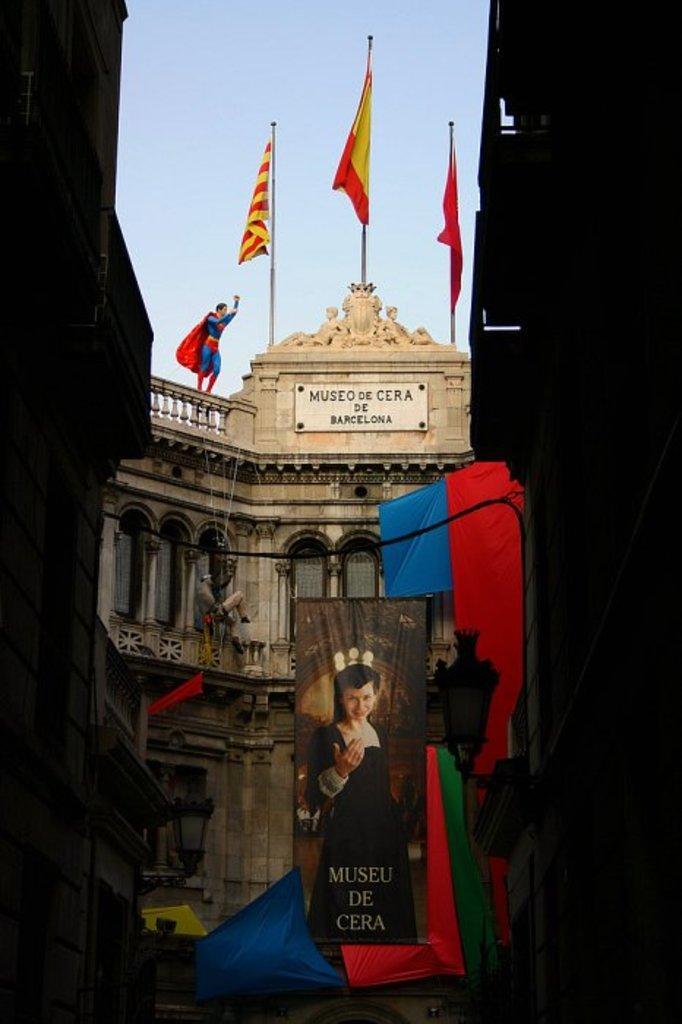Could you give a brief overview of what you see in this image? In the center of the image there are buildings, banners, flags. In the background of the image there is sky. There is a statue of a superman on top of the building. 